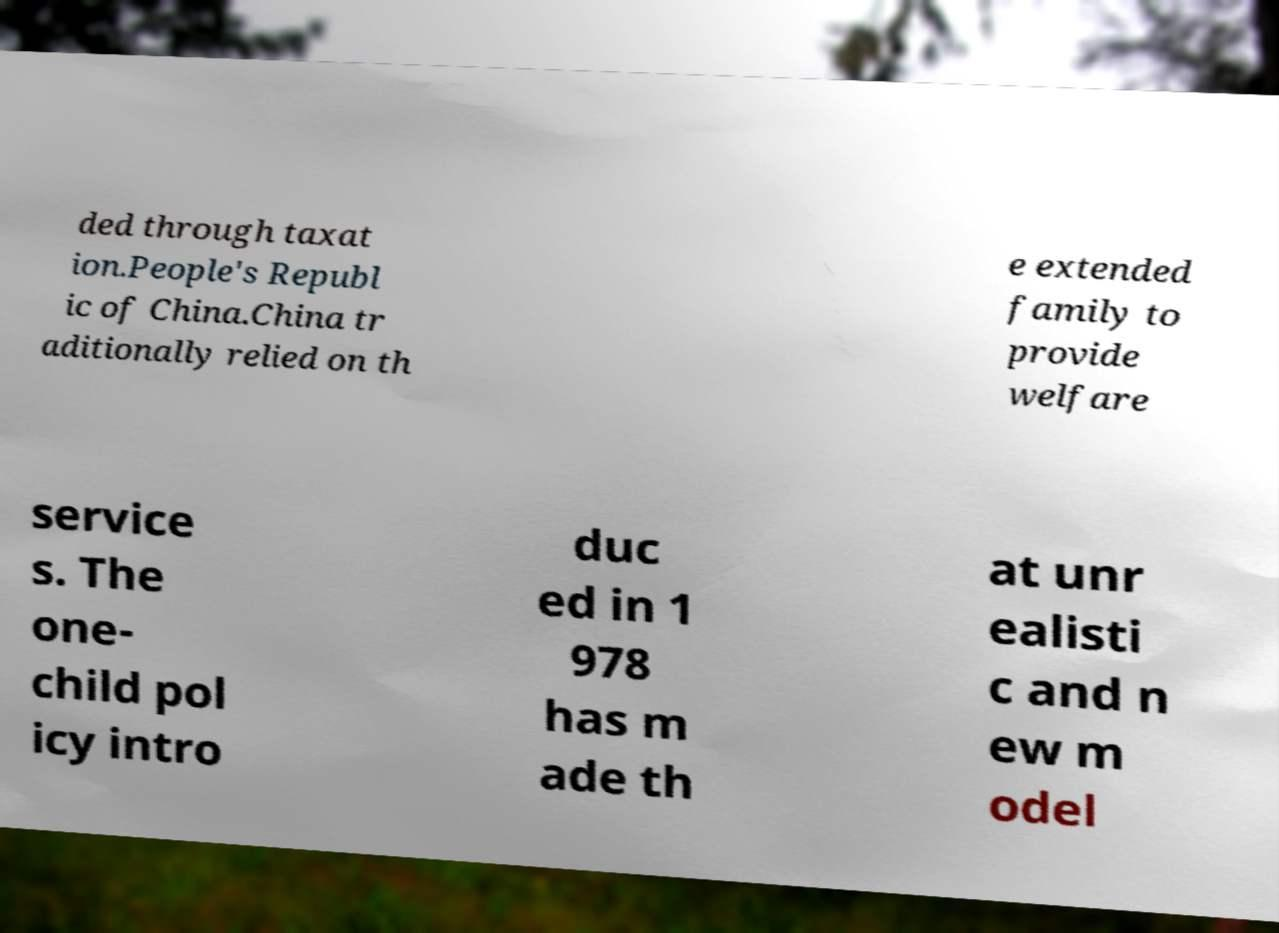There's text embedded in this image that I need extracted. Can you transcribe it verbatim? ded through taxat ion.People's Republ ic of China.China tr aditionally relied on th e extended family to provide welfare service s. The one- child pol icy intro duc ed in 1 978 has m ade th at unr ealisti c and n ew m odel 